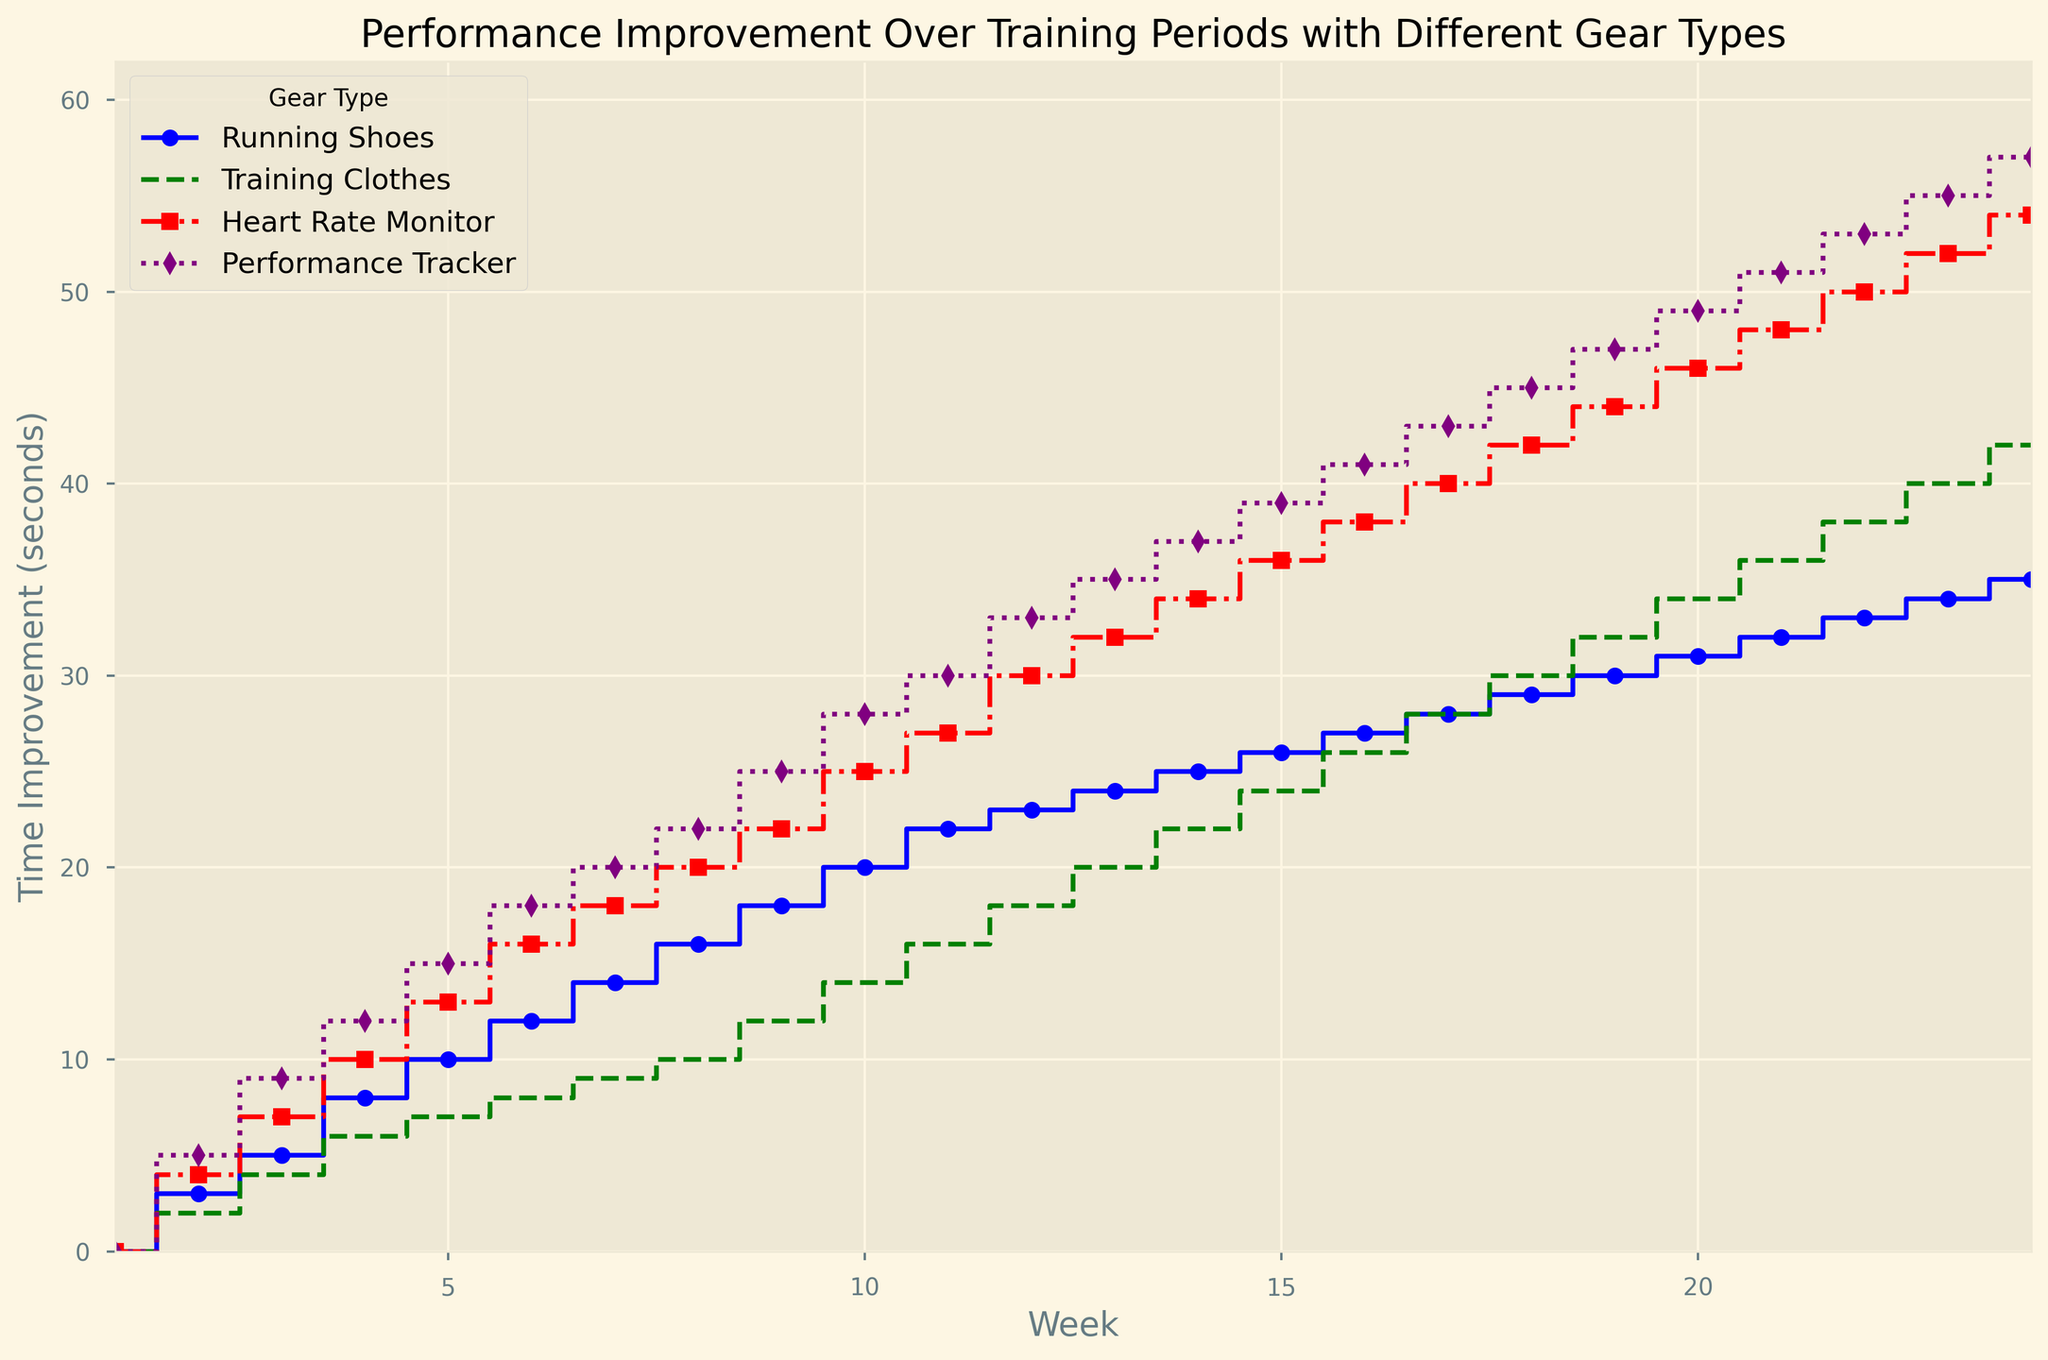Which gear type shows the greatest performance improvement after 24 weeks? After 24 weeks, Performance Tracker shows the greatest improvement in time, reaching 57 seconds as indicated by the highest point on the purple line.
Answer: Performance Tracker How many weeks does it take for the Heart Rate Monitor to surpass 30 seconds improvement? The red line representing Heart Rate Monitor surpasses 30 seconds at week 12, where it reaches exactly 30 seconds.
Answer: 12 weeks At week 6, how much more improvement does the Heart Rate Monitor show compared to Training Clothes? At week 6, the Heart Rate Monitor (red line) shows an improvement of 16 seconds, while Training Clothes (green line) show an improvement of 8 seconds. The difference is 16 - 8 = 8 seconds.
Answer: 8 seconds Which gear type reaches a 20-second performance improvement first? The Performance Tracker (purple line) reaches a 20-second improvement by week 8, the earliest among all gear types.
Answer: Performance Tracker Is the performance improvement of Running Shoes steady or sporadic over the 24 weeks? Provide a reason based on visual cues. The performance improvement for Running Shoes (blue line) appears steady, as the line increases gradually and consistently without sudden jumps or drops throughout the 24 weeks.
Answer: Steady By how many weeks does the Performance Tracker's improvement surpass the 40-second mark? The Performance Tracker (purple line) surpasses the 40-second mark by week 16.
Answer: 16 weeks Calculate the average performance improvement for Training Clothes at weeks 8, 16, and 24. The improvement for Training Clothes (green line) at weeks 8, 16, and 24 are 10, 26, and 42 seconds, respectively. The average is (10 + 26 + 42) / 3 = 78 / 3 = 26 seconds.
Answer: 26 seconds Which gear type shows the least improvement by week 10? By week 10, Training Clothes (green line) shows the least improvement with 14 seconds. The other improvements are 20 (Running Shoes), 25 (Heart Rate Monitor), and 28 (Performance Tracker).
Answer: Training Clothes 